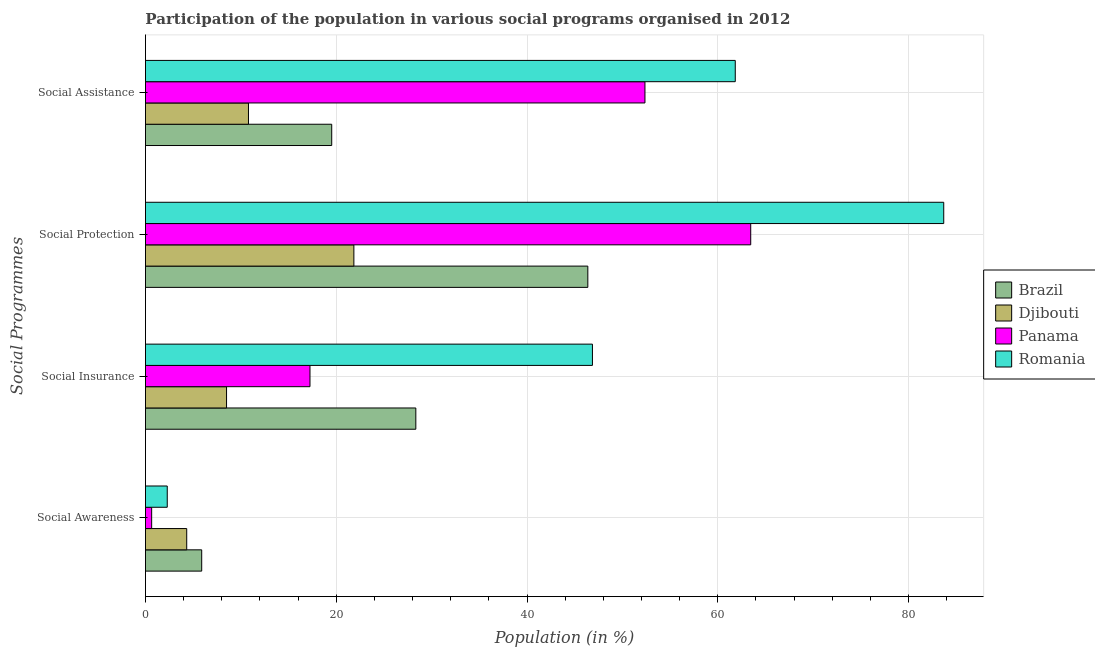How many different coloured bars are there?
Keep it short and to the point. 4. Are the number of bars per tick equal to the number of legend labels?
Make the answer very short. Yes. How many bars are there on the 3rd tick from the top?
Your answer should be compact. 4. How many bars are there on the 3rd tick from the bottom?
Ensure brevity in your answer.  4. What is the label of the 4th group of bars from the top?
Your answer should be compact. Social Awareness. What is the participation of population in social awareness programs in Panama?
Give a very brief answer. 0.65. Across all countries, what is the maximum participation of population in social awareness programs?
Your answer should be compact. 5.9. Across all countries, what is the minimum participation of population in social assistance programs?
Your response must be concise. 10.8. In which country was the participation of population in social assistance programs minimum?
Your response must be concise. Djibouti. What is the total participation of population in social insurance programs in the graph?
Keep it short and to the point. 100.96. What is the difference between the participation of population in social assistance programs in Brazil and that in Djibouti?
Ensure brevity in your answer.  8.73. What is the difference between the participation of population in social insurance programs in Panama and the participation of population in social awareness programs in Romania?
Make the answer very short. 14.96. What is the average participation of population in social protection programs per country?
Provide a succinct answer. 53.84. What is the difference between the participation of population in social awareness programs and participation of population in social assistance programs in Romania?
Your response must be concise. -59.55. What is the ratio of the participation of population in social insurance programs in Romania to that in Panama?
Your answer should be compact. 2.72. Is the difference between the participation of population in social assistance programs in Panama and Romania greater than the difference between the participation of population in social awareness programs in Panama and Romania?
Give a very brief answer. No. What is the difference between the highest and the second highest participation of population in social insurance programs?
Provide a short and direct response. 18.52. What is the difference between the highest and the lowest participation of population in social assistance programs?
Keep it short and to the point. 51.03. In how many countries, is the participation of population in social protection programs greater than the average participation of population in social protection programs taken over all countries?
Your answer should be very brief. 2. Is the sum of the participation of population in social assistance programs in Panama and Romania greater than the maximum participation of population in social awareness programs across all countries?
Keep it short and to the point. Yes. Is it the case that in every country, the sum of the participation of population in social assistance programs and participation of population in social awareness programs is greater than the sum of participation of population in social protection programs and participation of population in social insurance programs?
Your answer should be very brief. Yes. What does the 2nd bar from the top in Social Awareness represents?
Offer a very short reply. Panama. What does the 2nd bar from the bottom in Social Assistance represents?
Offer a terse response. Djibouti. Are all the bars in the graph horizontal?
Ensure brevity in your answer.  Yes. What is the difference between two consecutive major ticks on the X-axis?
Offer a terse response. 20. Are the values on the major ticks of X-axis written in scientific E-notation?
Keep it short and to the point. No. Does the graph contain any zero values?
Your answer should be compact. No. Does the graph contain grids?
Provide a succinct answer. Yes. How many legend labels are there?
Your answer should be compact. 4. What is the title of the graph?
Provide a succinct answer. Participation of the population in various social programs organised in 2012. What is the label or title of the X-axis?
Offer a terse response. Population (in %). What is the label or title of the Y-axis?
Offer a terse response. Social Programmes. What is the Population (in %) of Brazil in Social Awareness?
Keep it short and to the point. 5.9. What is the Population (in %) in Djibouti in Social Awareness?
Your answer should be compact. 4.33. What is the Population (in %) in Panama in Social Awareness?
Ensure brevity in your answer.  0.65. What is the Population (in %) of Romania in Social Awareness?
Give a very brief answer. 2.28. What is the Population (in %) in Brazil in Social Insurance?
Keep it short and to the point. 28.34. What is the Population (in %) in Djibouti in Social Insurance?
Give a very brief answer. 8.5. What is the Population (in %) of Panama in Social Insurance?
Offer a very short reply. 17.25. What is the Population (in %) in Romania in Social Insurance?
Offer a terse response. 46.86. What is the Population (in %) in Brazil in Social Protection?
Ensure brevity in your answer.  46.38. What is the Population (in %) of Djibouti in Social Protection?
Offer a very short reply. 21.85. What is the Population (in %) in Panama in Social Protection?
Provide a short and direct response. 63.45. What is the Population (in %) of Romania in Social Protection?
Give a very brief answer. 83.69. What is the Population (in %) of Brazil in Social Assistance?
Your answer should be very brief. 19.53. What is the Population (in %) in Djibouti in Social Assistance?
Your response must be concise. 10.8. What is the Population (in %) of Panama in Social Assistance?
Your answer should be very brief. 52.37. What is the Population (in %) of Romania in Social Assistance?
Your answer should be compact. 61.83. Across all Social Programmes, what is the maximum Population (in %) in Brazil?
Your answer should be very brief. 46.38. Across all Social Programmes, what is the maximum Population (in %) of Djibouti?
Ensure brevity in your answer.  21.85. Across all Social Programmes, what is the maximum Population (in %) of Panama?
Ensure brevity in your answer.  63.45. Across all Social Programmes, what is the maximum Population (in %) in Romania?
Offer a very short reply. 83.69. Across all Social Programmes, what is the minimum Population (in %) of Brazil?
Offer a very short reply. 5.9. Across all Social Programmes, what is the minimum Population (in %) of Djibouti?
Give a very brief answer. 4.33. Across all Social Programmes, what is the minimum Population (in %) of Panama?
Provide a succinct answer. 0.65. Across all Social Programmes, what is the minimum Population (in %) in Romania?
Your answer should be very brief. 2.28. What is the total Population (in %) in Brazil in the graph?
Your answer should be compact. 100.15. What is the total Population (in %) in Djibouti in the graph?
Your answer should be very brief. 45.48. What is the total Population (in %) of Panama in the graph?
Provide a short and direct response. 133.72. What is the total Population (in %) of Romania in the graph?
Your answer should be compact. 194.67. What is the difference between the Population (in %) of Brazil in Social Awareness and that in Social Insurance?
Offer a terse response. -22.45. What is the difference between the Population (in %) in Djibouti in Social Awareness and that in Social Insurance?
Provide a succinct answer. -4.18. What is the difference between the Population (in %) of Panama in Social Awareness and that in Social Insurance?
Make the answer very short. -16.6. What is the difference between the Population (in %) of Romania in Social Awareness and that in Social Insurance?
Your answer should be compact. -44.58. What is the difference between the Population (in %) in Brazil in Social Awareness and that in Social Protection?
Make the answer very short. -40.48. What is the difference between the Population (in %) of Djibouti in Social Awareness and that in Social Protection?
Offer a terse response. -17.52. What is the difference between the Population (in %) of Panama in Social Awareness and that in Social Protection?
Your answer should be compact. -62.8. What is the difference between the Population (in %) in Romania in Social Awareness and that in Social Protection?
Provide a short and direct response. -81.4. What is the difference between the Population (in %) in Brazil in Social Awareness and that in Social Assistance?
Your answer should be compact. -13.63. What is the difference between the Population (in %) in Djibouti in Social Awareness and that in Social Assistance?
Make the answer very short. -6.47. What is the difference between the Population (in %) of Panama in Social Awareness and that in Social Assistance?
Give a very brief answer. -51.72. What is the difference between the Population (in %) in Romania in Social Awareness and that in Social Assistance?
Provide a succinct answer. -59.55. What is the difference between the Population (in %) in Brazil in Social Insurance and that in Social Protection?
Provide a short and direct response. -18.03. What is the difference between the Population (in %) in Djibouti in Social Insurance and that in Social Protection?
Your answer should be very brief. -13.35. What is the difference between the Population (in %) in Panama in Social Insurance and that in Social Protection?
Give a very brief answer. -46.2. What is the difference between the Population (in %) of Romania in Social Insurance and that in Social Protection?
Offer a terse response. -36.83. What is the difference between the Population (in %) of Brazil in Social Insurance and that in Social Assistance?
Provide a succinct answer. 8.82. What is the difference between the Population (in %) of Djibouti in Social Insurance and that in Social Assistance?
Your answer should be very brief. -2.3. What is the difference between the Population (in %) in Panama in Social Insurance and that in Social Assistance?
Your answer should be very brief. -35.12. What is the difference between the Population (in %) in Romania in Social Insurance and that in Social Assistance?
Offer a very short reply. -14.97. What is the difference between the Population (in %) in Brazil in Social Protection and that in Social Assistance?
Give a very brief answer. 26.85. What is the difference between the Population (in %) in Djibouti in Social Protection and that in Social Assistance?
Your answer should be very brief. 11.05. What is the difference between the Population (in %) of Panama in Social Protection and that in Social Assistance?
Offer a very short reply. 11.09. What is the difference between the Population (in %) in Romania in Social Protection and that in Social Assistance?
Your response must be concise. 21.86. What is the difference between the Population (in %) in Brazil in Social Awareness and the Population (in %) in Djibouti in Social Insurance?
Ensure brevity in your answer.  -2.6. What is the difference between the Population (in %) of Brazil in Social Awareness and the Population (in %) of Panama in Social Insurance?
Provide a succinct answer. -11.35. What is the difference between the Population (in %) of Brazil in Social Awareness and the Population (in %) of Romania in Social Insurance?
Keep it short and to the point. -40.96. What is the difference between the Population (in %) in Djibouti in Social Awareness and the Population (in %) in Panama in Social Insurance?
Ensure brevity in your answer.  -12.92. What is the difference between the Population (in %) in Djibouti in Social Awareness and the Population (in %) in Romania in Social Insurance?
Provide a short and direct response. -42.53. What is the difference between the Population (in %) of Panama in Social Awareness and the Population (in %) of Romania in Social Insurance?
Make the answer very short. -46.21. What is the difference between the Population (in %) of Brazil in Social Awareness and the Population (in %) of Djibouti in Social Protection?
Provide a short and direct response. -15.95. What is the difference between the Population (in %) in Brazil in Social Awareness and the Population (in %) in Panama in Social Protection?
Ensure brevity in your answer.  -57.56. What is the difference between the Population (in %) in Brazil in Social Awareness and the Population (in %) in Romania in Social Protection?
Make the answer very short. -77.79. What is the difference between the Population (in %) in Djibouti in Social Awareness and the Population (in %) in Panama in Social Protection?
Give a very brief answer. -59.13. What is the difference between the Population (in %) in Djibouti in Social Awareness and the Population (in %) in Romania in Social Protection?
Provide a succinct answer. -79.36. What is the difference between the Population (in %) in Panama in Social Awareness and the Population (in %) in Romania in Social Protection?
Provide a short and direct response. -83.04. What is the difference between the Population (in %) in Brazil in Social Awareness and the Population (in %) in Djibouti in Social Assistance?
Your response must be concise. -4.9. What is the difference between the Population (in %) in Brazil in Social Awareness and the Population (in %) in Panama in Social Assistance?
Your response must be concise. -46.47. What is the difference between the Population (in %) of Brazil in Social Awareness and the Population (in %) of Romania in Social Assistance?
Make the answer very short. -55.94. What is the difference between the Population (in %) in Djibouti in Social Awareness and the Population (in %) in Panama in Social Assistance?
Provide a succinct answer. -48.04. What is the difference between the Population (in %) in Djibouti in Social Awareness and the Population (in %) in Romania in Social Assistance?
Provide a short and direct response. -57.51. What is the difference between the Population (in %) in Panama in Social Awareness and the Population (in %) in Romania in Social Assistance?
Your answer should be very brief. -61.18. What is the difference between the Population (in %) in Brazil in Social Insurance and the Population (in %) in Djibouti in Social Protection?
Offer a terse response. 6.49. What is the difference between the Population (in %) of Brazil in Social Insurance and the Population (in %) of Panama in Social Protection?
Make the answer very short. -35.11. What is the difference between the Population (in %) in Brazil in Social Insurance and the Population (in %) in Romania in Social Protection?
Give a very brief answer. -55.34. What is the difference between the Population (in %) in Djibouti in Social Insurance and the Population (in %) in Panama in Social Protection?
Provide a succinct answer. -54.95. What is the difference between the Population (in %) in Djibouti in Social Insurance and the Population (in %) in Romania in Social Protection?
Offer a terse response. -75.19. What is the difference between the Population (in %) in Panama in Social Insurance and the Population (in %) in Romania in Social Protection?
Give a very brief answer. -66.44. What is the difference between the Population (in %) of Brazil in Social Insurance and the Population (in %) of Djibouti in Social Assistance?
Make the answer very short. 17.54. What is the difference between the Population (in %) of Brazil in Social Insurance and the Population (in %) of Panama in Social Assistance?
Provide a short and direct response. -24.02. What is the difference between the Population (in %) in Brazil in Social Insurance and the Population (in %) in Romania in Social Assistance?
Offer a terse response. -33.49. What is the difference between the Population (in %) of Djibouti in Social Insurance and the Population (in %) of Panama in Social Assistance?
Keep it short and to the point. -43.86. What is the difference between the Population (in %) of Djibouti in Social Insurance and the Population (in %) of Romania in Social Assistance?
Provide a succinct answer. -53.33. What is the difference between the Population (in %) of Panama in Social Insurance and the Population (in %) of Romania in Social Assistance?
Keep it short and to the point. -44.58. What is the difference between the Population (in %) in Brazil in Social Protection and the Population (in %) in Djibouti in Social Assistance?
Provide a short and direct response. 35.58. What is the difference between the Population (in %) of Brazil in Social Protection and the Population (in %) of Panama in Social Assistance?
Your response must be concise. -5.99. What is the difference between the Population (in %) of Brazil in Social Protection and the Population (in %) of Romania in Social Assistance?
Ensure brevity in your answer.  -15.46. What is the difference between the Population (in %) of Djibouti in Social Protection and the Population (in %) of Panama in Social Assistance?
Keep it short and to the point. -30.52. What is the difference between the Population (in %) of Djibouti in Social Protection and the Population (in %) of Romania in Social Assistance?
Offer a very short reply. -39.98. What is the difference between the Population (in %) of Panama in Social Protection and the Population (in %) of Romania in Social Assistance?
Your answer should be compact. 1.62. What is the average Population (in %) of Brazil per Social Programmes?
Offer a very short reply. 25.04. What is the average Population (in %) in Djibouti per Social Programmes?
Offer a terse response. 11.37. What is the average Population (in %) in Panama per Social Programmes?
Provide a succinct answer. 33.43. What is the average Population (in %) of Romania per Social Programmes?
Make the answer very short. 48.67. What is the difference between the Population (in %) in Brazil and Population (in %) in Djibouti in Social Awareness?
Offer a terse response. 1.57. What is the difference between the Population (in %) in Brazil and Population (in %) in Panama in Social Awareness?
Your response must be concise. 5.25. What is the difference between the Population (in %) in Brazil and Population (in %) in Romania in Social Awareness?
Your answer should be compact. 3.61. What is the difference between the Population (in %) of Djibouti and Population (in %) of Panama in Social Awareness?
Your answer should be very brief. 3.68. What is the difference between the Population (in %) of Djibouti and Population (in %) of Romania in Social Awareness?
Offer a very short reply. 2.04. What is the difference between the Population (in %) of Panama and Population (in %) of Romania in Social Awareness?
Offer a terse response. -1.64. What is the difference between the Population (in %) of Brazil and Population (in %) of Djibouti in Social Insurance?
Ensure brevity in your answer.  19.84. What is the difference between the Population (in %) in Brazil and Population (in %) in Panama in Social Insurance?
Offer a terse response. 11.1. What is the difference between the Population (in %) of Brazil and Population (in %) of Romania in Social Insurance?
Ensure brevity in your answer.  -18.52. What is the difference between the Population (in %) of Djibouti and Population (in %) of Panama in Social Insurance?
Make the answer very short. -8.75. What is the difference between the Population (in %) in Djibouti and Population (in %) in Romania in Social Insurance?
Make the answer very short. -38.36. What is the difference between the Population (in %) in Panama and Population (in %) in Romania in Social Insurance?
Make the answer very short. -29.61. What is the difference between the Population (in %) in Brazil and Population (in %) in Djibouti in Social Protection?
Your answer should be very brief. 24.53. What is the difference between the Population (in %) in Brazil and Population (in %) in Panama in Social Protection?
Ensure brevity in your answer.  -17.08. What is the difference between the Population (in %) of Brazil and Population (in %) of Romania in Social Protection?
Keep it short and to the point. -37.31. What is the difference between the Population (in %) in Djibouti and Population (in %) in Panama in Social Protection?
Provide a short and direct response. -41.6. What is the difference between the Population (in %) of Djibouti and Population (in %) of Romania in Social Protection?
Your response must be concise. -61.84. What is the difference between the Population (in %) of Panama and Population (in %) of Romania in Social Protection?
Make the answer very short. -20.23. What is the difference between the Population (in %) in Brazil and Population (in %) in Djibouti in Social Assistance?
Ensure brevity in your answer.  8.73. What is the difference between the Population (in %) of Brazil and Population (in %) of Panama in Social Assistance?
Your answer should be compact. -32.84. What is the difference between the Population (in %) of Brazil and Population (in %) of Romania in Social Assistance?
Provide a short and direct response. -42.31. What is the difference between the Population (in %) of Djibouti and Population (in %) of Panama in Social Assistance?
Give a very brief answer. -41.57. What is the difference between the Population (in %) of Djibouti and Population (in %) of Romania in Social Assistance?
Your answer should be very brief. -51.03. What is the difference between the Population (in %) of Panama and Population (in %) of Romania in Social Assistance?
Make the answer very short. -9.47. What is the ratio of the Population (in %) in Brazil in Social Awareness to that in Social Insurance?
Make the answer very short. 0.21. What is the ratio of the Population (in %) in Djibouti in Social Awareness to that in Social Insurance?
Give a very brief answer. 0.51. What is the ratio of the Population (in %) of Panama in Social Awareness to that in Social Insurance?
Offer a terse response. 0.04. What is the ratio of the Population (in %) of Romania in Social Awareness to that in Social Insurance?
Your response must be concise. 0.05. What is the ratio of the Population (in %) of Brazil in Social Awareness to that in Social Protection?
Offer a terse response. 0.13. What is the ratio of the Population (in %) of Djibouti in Social Awareness to that in Social Protection?
Ensure brevity in your answer.  0.2. What is the ratio of the Population (in %) of Panama in Social Awareness to that in Social Protection?
Ensure brevity in your answer.  0.01. What is the ratio of the Population (in %) in Romania in Social Awareness to that in Social Protection?
Offer a terse response. 0.03. What is the ratio of the Population (in %) in Brazil in Social Awareness to that in Social Assistance?
Your answer should be compact. 0.3. What is the ratio of the Population (in %) in Djibouti in Social Awareness to that in Social Assistance?
Provide a short and direct response. 0.4. What is the ratio of the Population (in %) in Panama in Social Awareness to that in Social Assistance?
Make the answer very short. 0.01. What is the ratio of the Population (in %) in Romania in Social Awareness to that in Social Assistance?
Keep it short and to the point. 0.04. What is the ratio of the Population (in %) of Brazil in Social Insurance to that in Social Protection?
Provide a short and direct response. 0.61. What is the ratio of the Population (in %) of Djibouti in Social Insurance to that in Social Protection?
Offer a terse response. 0.39. What is the ratio of the Population (in %) in Panama in Social Insurance to that in Social Protection?
Provide a short and direct response. 0.27. What is the ratio of the Population (in %) in Romania in Social Insurance to that in Social Protection?
Ensure brevity in your answer.  0.56. What is the ratio of the Population (in %) in Brazil in Social Insurance to that in Social Assistance?
Give a very brief answer. 1.45. What is the ratio of the Population (in %) in Djibouti in Social Insurance to that in Social Assistance?
Your answer should be very brief. 0.79. What is the ratio of the Population (in %) of Panama in Social Insurance to that in Social Assistance?
Offer a terse response. 0.33. What is the ratio of the Population (in %) of Romania in Social Insurance to that in Social Assistance?
Your answer should be compact. 0.76. What is the ratio of the Population (in %) of Brazil in Social Protection to that in Social Assistance?
Provide a short and direct response. 2.37. What is the ratio of the Population (in %) of Djibouti in Social Protection to that in Social Assistance?
Make the answer very short. 2.02. What is the ratio of the Population (in %) of Panama in Social Protection to that in Social Assistance?
Your response must be concise. 1.21. What is the ratio of the Population (in %) of Romania in Social Protection to that in Social Assistance?
Offer a very short reply. 1.35. What is the difference between the highest and the second highest Population (in %) in Brazil?
Your answer should be compact. 18.03. What is the difference between the highest and the second highest Population (in %) in Djibouti?
Make the answer very short. 11.05. What is the difference between the highest and the second highest Population (in %) of Panama?
Ensure brevity in your answer.  11.09. What is the difference between the highest and the second highest Population (in %) of Romania?
Offer a terse response. 21.86. What is the difference between the highest and the lowest Population (in %) in Brazil?
Provide a short and direct response. 40.48. What is the difference between the highest and the lowest Population (in %) of Djibouti?
Provide a short and direct response. 17.52. What is the difference between the highest and the lowest Population (in %) in Panama?
Your answer should be very brief. 62.8. What is the difference between the highest and the lowest Population (in %) of Romania?
Provide a succinct answer. 81.4. 